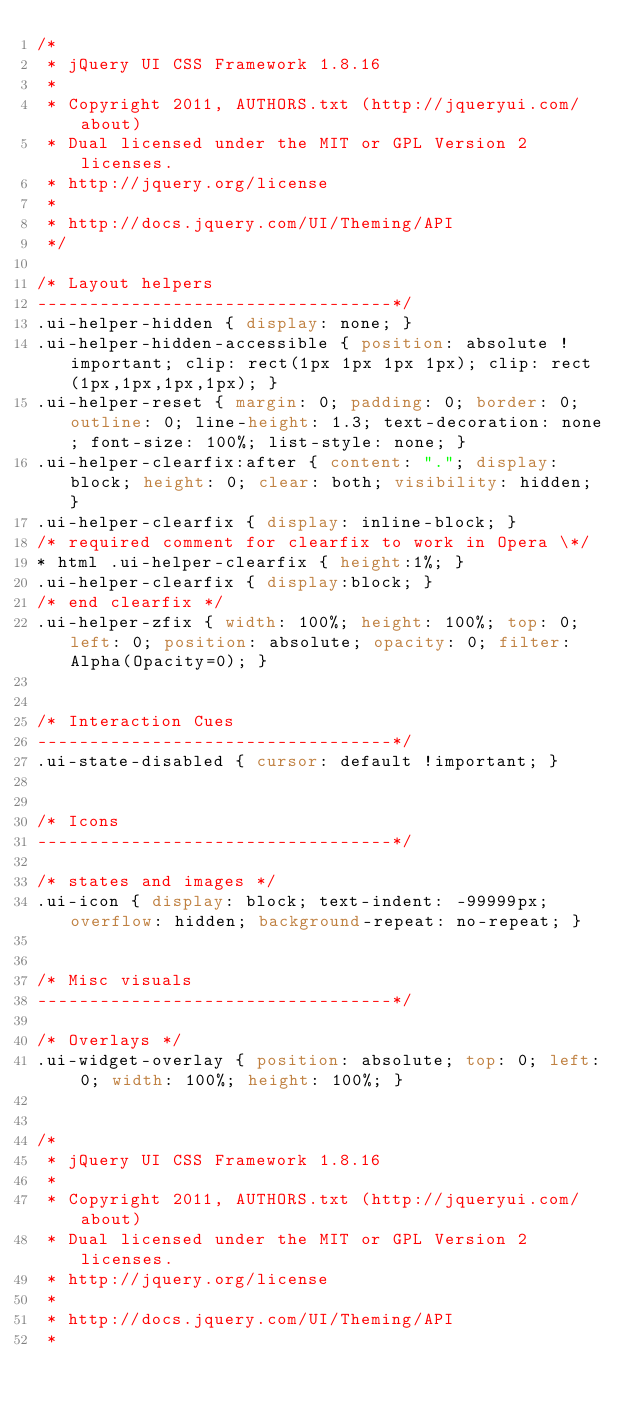<code> <loc_0><loc_0><loc_500><loc_500><_CSS_>/*
 * jQuery UI CSS Framework 1.8.16
 *
 * Copyright 2011, AUTHORS.txt (http://jqueryui.com/about)
 * Dual licensed under the MIT or GPL Version 2 licenses.
 * http://jquery.org/license
 *
 * http://docs.jquery.com/UI/Theming/API
 */

/* Layout helpers
----------------------------------*/
.ui-helper-hidden { display: none; }
.ui-helper-hidden-accessible { position: absolute !important; clip: rect(1px 1px 1px 1px); clip: rect(1px,1px,1px,1px); }
.ui-helper-reset { margin: 0; padding: 0; border: 0; outline: 0; line-height: 1.3; text-decoration: none; font-size: 100%; list-style: none; }
.ui-helper-clearfix:after { content: "."; display: block; height: 0; clear: both; visibility: hidden; }
.ui-helper-clearfix { display: inline-block; }
/* required comment for clearfix to work in Opera \*/
* html .ui-helper-clearfix { height:1%; }
.ui-helper-clearfix { display:block; }
/* end clearfix */
.ui-helper-zfix { width: 100%; height: 100%; top: 0; left: 0; position: absolute; opacity: 0; filter:Alpha(Opacity=0); }


/* Interaction Cues
----------------------------------*/
.ui-state-disabled { cursor: default !important; }


/* Icons
----------------------------------*/

/* states and images */
.ui-icon { display: block; text-indent: -99999px; overflow: hidden; background-repeat: no-repeat; }


/* Misc visuals
----------------------------------*/

/* Overlays */
.ui-widget-overlay { position: absolute; top: 0; left: 0; width: 100%; height: 100%; }


/*
 * jQuery UI CSS Framework 1.8.16
 *
 * Copyright 2011, AUTHORS.txt (http://jqueryui.com/about)
 * Dual licensed under the MIT or GPL Version 2 licenses.
 * http://jquery.org/license
 *
 * http://docs.jquery.com/UI/Theming/API
 *</code> 